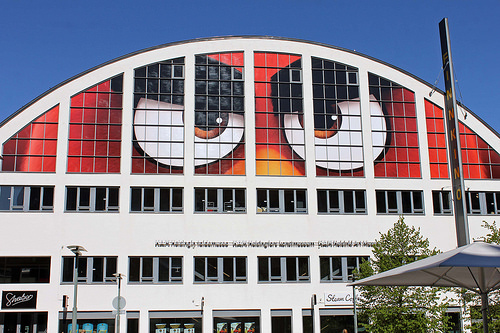<image>
Can you confirm if the eyeball is on the building? Yes. Looking at the image, I can see the eyeball is positioned on top of the building, with the building providing support. 